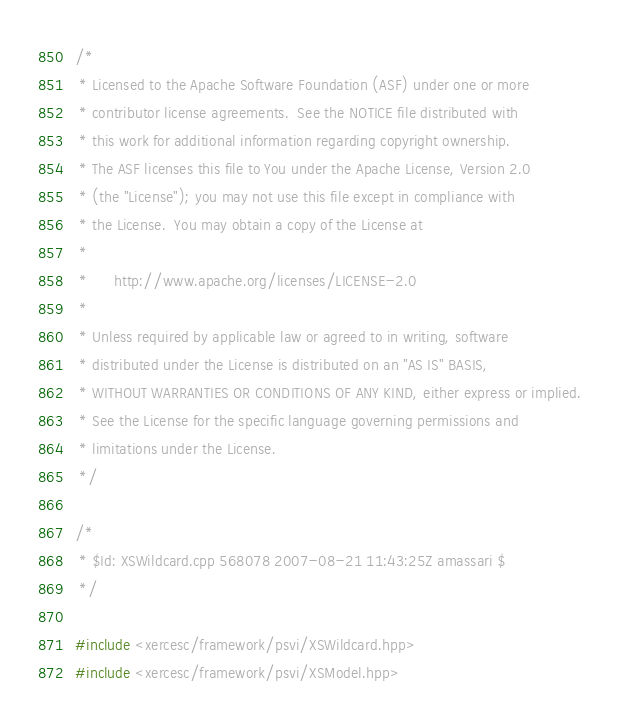<code> <loc_0><loc_0><loc_500><loc_500><_C++_>/*
 * Licensed to the Apache Software Foundation (ASF) under one or more
 * contributor license agreements.  See the NOTICE file distributed with
 * this work for additional information regarding copyright ownership.
 * The ASF licenses this file to You under the Apache License, Version 2.0
 * (the "License"); you may not use this file except in compliance with
 * the License.  You may obtain a copy of the License at
 * 
 *      http://www.apache.org/licenses/LICENSE-2.0
 * 
 * Unless required by applicable law or agreed to in writing, software
 * distributed under the License is distributed on an "AS IS" BASIS,
 * WITHOUT WARRANTIES OR CONDITIONS OF ANY KIND, either express or implied.
 * See the License for the specific language governing permissions and
 * limitations under the License.
 */

/*
 * $Id: XSWildcard.cpp 568078 2007-08-21 11:43:25Z amassari $
 */

#include <xercesc/framework/psvi/XSWildcard.hpp>
#include <xercesc/framework/psvi/XSModel.hpp></code> 